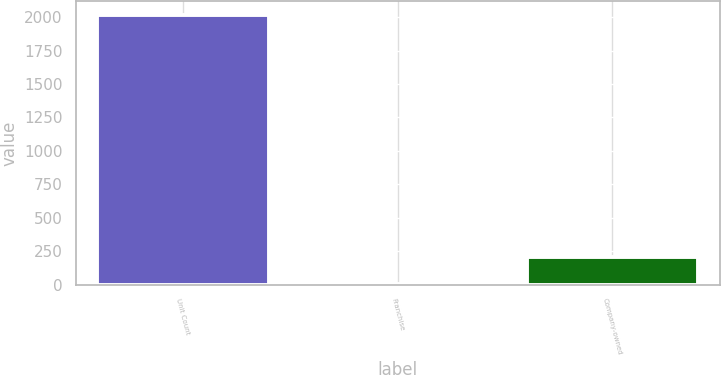<chart> <loc_0><loc_0><loc_500><loc_500><bar_chart><fcel>Unit Count<fcel>Franchise<fcel>Company-owned<nl><fcel>2017<fcel>7<fcel>208<nl></chart> 